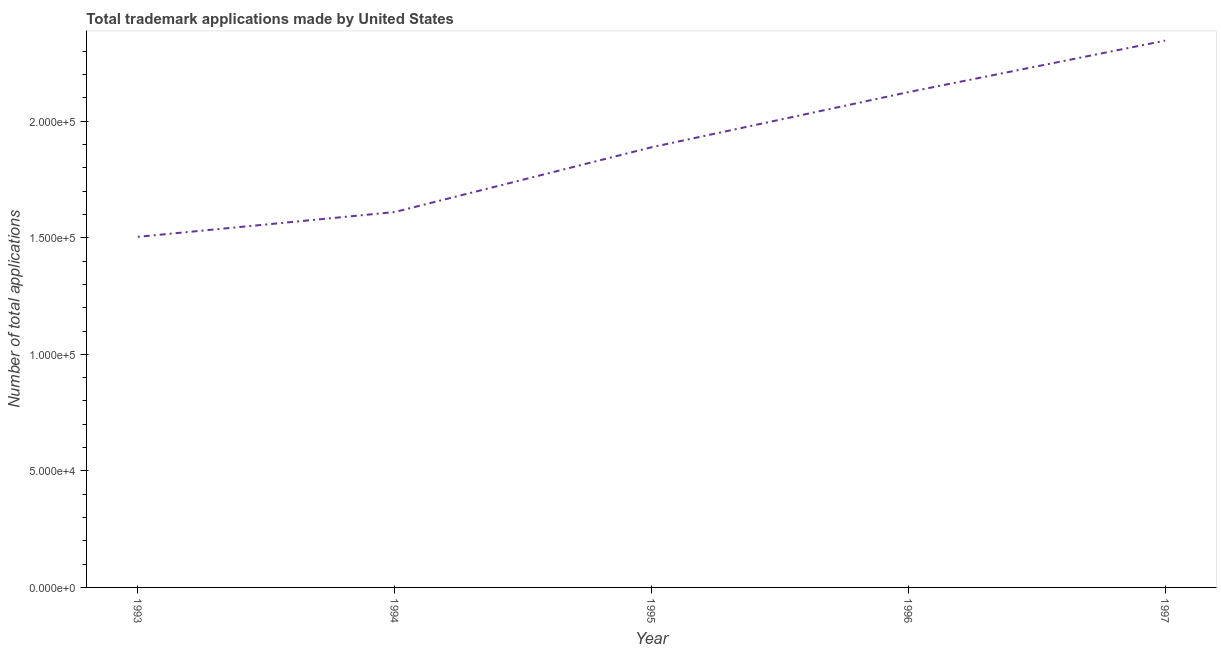What is the number of trademark applications in 1996?
Provide a short and direct response. 2.13e+05. Across all years, what is the maximum number of trademark applications?
Keep it short and to the point. 2.35e+05. Across all years, what is the minimum number of trademark applications?
Offer a terse response. 1.50e+05. What is the sum of the number of trademark applications?
Offer a very short reply. 9.47e+05. What is the difference between the number of trademark applications in 1993 and 1994?
Your answer should be compact. -1.06e+04. What is the average number of trademark applications per year?
Your response must be concise. 1.89e+05. What is the median number of trademark applications?
Keep it short and to the point. 1.89e+05. In how many years, is the number of trademark applications greater than 180000 ?
Keep it short and to the point. 3. What is the ratio of the number of trademark applications in 1994 to that in 1995?
Give a very brief answer. 0.85. Is the difference between the number of trademark applications in 1996 and 1997 greater than the difference between any two years?
Give a very brief answer. No. What is the difference between the highest and the second highest number of trademark applications?
Give a very brief answer. 2.21e+04. What is the difference between the highest and the lowest number of trademark applications?
Keep it short and to the point. 8.42e+04. In how many years, is the number of trademark applications greater than the average number of trademark applications taken over all years?
Your answer should be very brief. 2. How many lines are there?
Offer a terse response. 1. What is the difference between two consecutive major ticks on the Y-axis?
Provide a succinct answer. 5.00e+04. Are the values on the major ticks of Y-axis written in scientific E-notation?
Your answer should be very brief. Yes. Does the graph contain any zero values?
Your answer should be compact. No. Does the graph contain grids?
Your answer should be compact. No. What is the title of the graph?
Provide a succinct answer. Total trademark applications made by United States. What is the label or title of the Y-axis?
Keep it short and to the point. Number of total applications. What is the Number of total applications in 1993?
Ensure brevity in your answer.  1.50e+05. What is the Number of total applications of 1994?
Make the answer very short. 1.61e+05. What is the Number of total applications of 1995?
Ensure brevity in your answer.  1.89e+05. What is the Number of total applications in 1996?
Provide a short and direct response. 2.13e+05. What is the Number of total applications in 1997?
Provide a short and direct response. 2.35e+05. What is the difference between the Number of total applications in 1993 and 1994?
Offer a very short reply. -1.06e+04. What is the difference between the Number of total applications in 1993 and 1995?
Give a very brief answer. -3.84e+04. What is the difference between the Number of total applications in 1993 and 1996?
Keep it short and to the point. -6.21e+04. What is the difference between the Number of total applications in 1993 and 1997?
Provide a succinct answer. -8.42e+04. What is the difference between the Number of total applications in 1994 and 1995?
Your answer should be very brief. -2.78e+04. What is the difference between the Number of total applications in 1994 and 1996?
Keep it short and to the point. -5.15e+04. What is the difference between the Number of total applications in 1994 and 1997?
Provide a short and direct response. -7.36e+04. What is the difference between the Number of total applications in 1995 and 1996?
Give a very brief answer. -2.37e+04. What is the difference between the Number of total applications in 1995 and 1997?
Provide a short and direct response. -4.58e+04. What is the difference between the Number of total applications in 1996 and 1997?
Your response must be concise. -2.21e+04. What is the ratio of the Number of total applications in 1993 to that in 1994?
Your answer should be very brief. 0.93. What is the ratio of the Number of total applications in 1993 to that in 1995?
Give a very brief answer. 0.8. What is the ratio of the Number of total applications in 1993 to that in 1996?
Your answer should be very brief. 0.71. What is the ratio of the Number of total applications in 1993 to that in 1997?
Offer a very short reply. 0.64. What is the ratio of the Number of total applications in 1994 to that in 1995?
Your answer should be very brief. 0.85. What is the ratio of the Number of total applications in 1994 to that in 1996?
Give a very brief answer. 0.76. What is the ratio of the Number of total applications in 1994 to that in 1997?
Your answer should be very brief. 0.69. What is the ratio of the Number of total applications in 1995 to that in 1996?
Provide a succinct answer. 0.89. What is the ratio of the Number of total applications in 1995 to that in 1997?
Keep it short and to the point. 0.81. What is the ratio of the Number of total applications in 1996 to that in 1997?
Your answer should be compact. 0.91. 